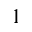<formula> <loc_0><loc_0><loc_500><loc_500>_ { 1 }</formula> 